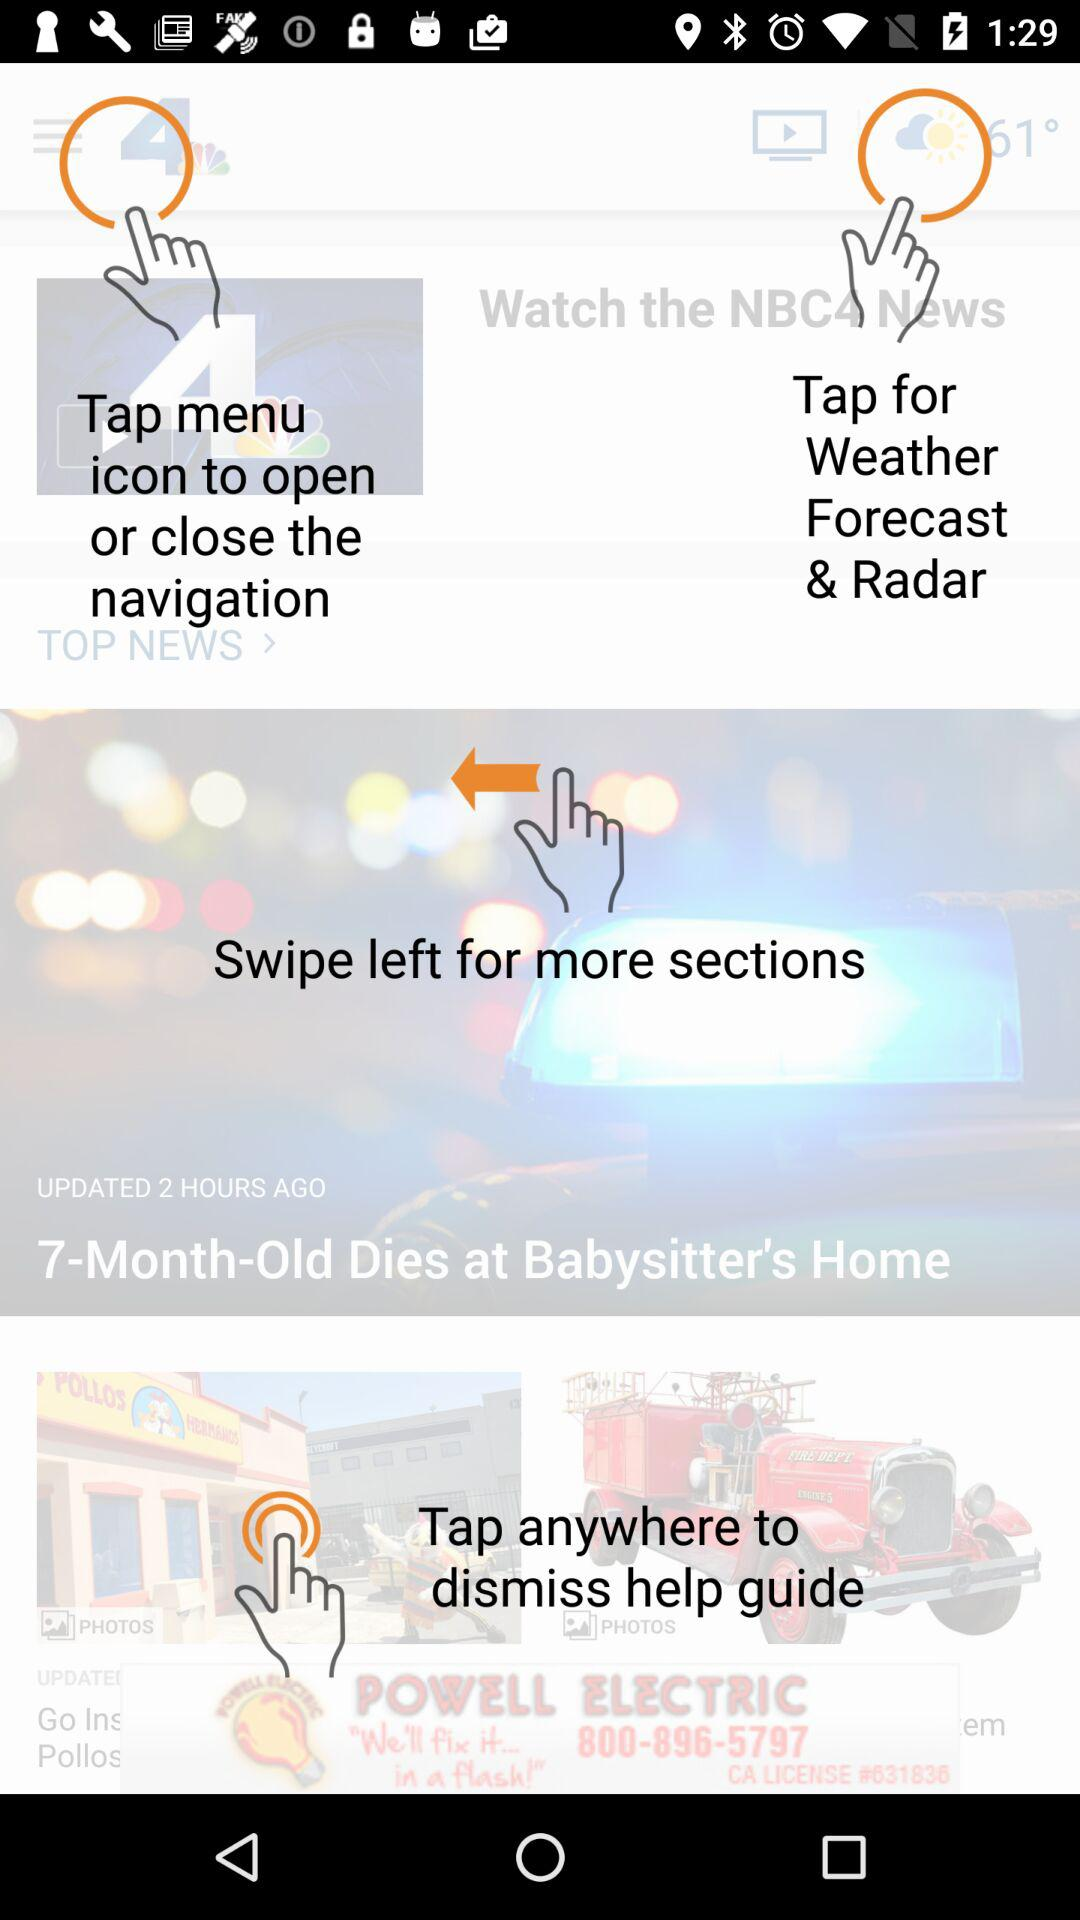When was the news "7-Month-Old Dies at Babysitter's Home" updated? The news "7-Month-Old Dies at Babysitter's Home" was updated 2 hours ago. 